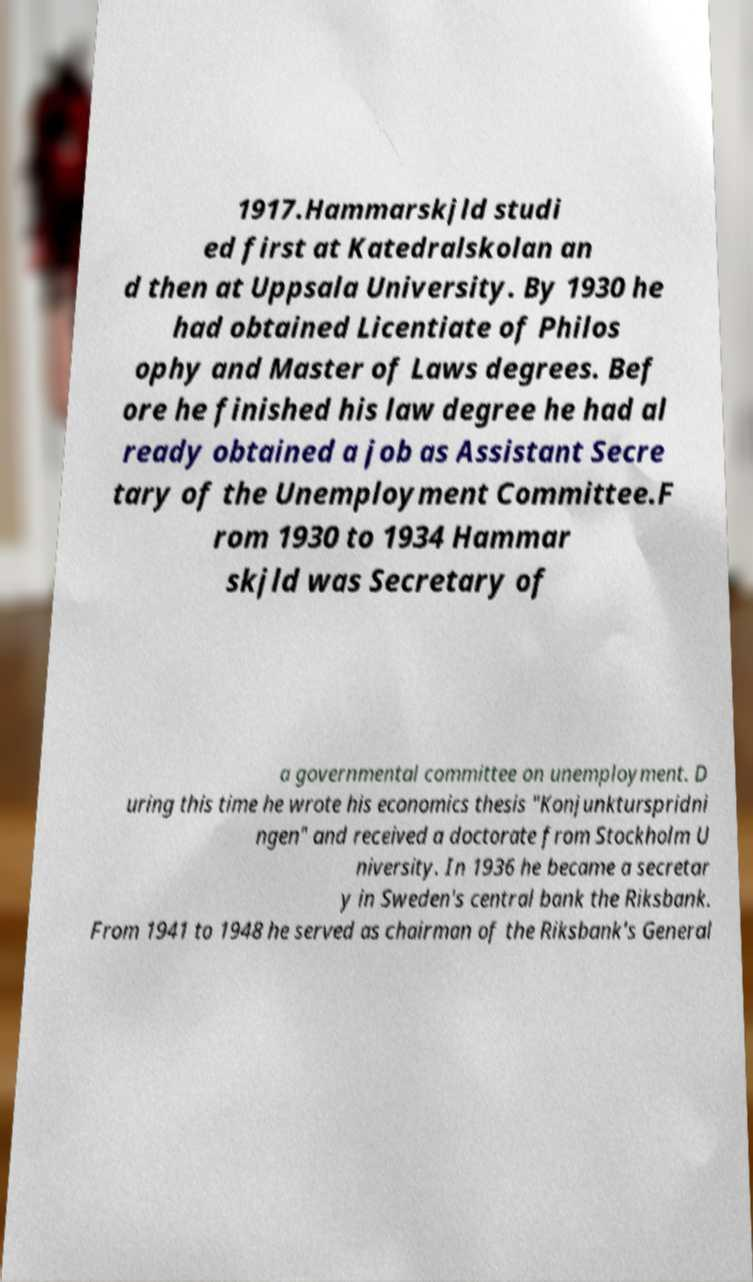Please read and relay the text visible in this image. What does it say? 1917.Hammarskjld studi ed first at Katedralskolan an d then at Uppsala University. By 1930 he had obtained Licentiate of Philos ophy and Master of Laws degrees. Bef ore he finished his law degree he had al ready obtained a job as Assistant Secre tary of the Unemployment Committee.F rom 1930 to 1934 Hammar skjld was Secretary of a governmental committee on unemployment. D uring this time he wrote his economics thesis "Konjunkturspridni ngen" and received a doctorate from Stockholm U niversity. In 1936 he became a secretar y in Sweden's central bank the Riksbank. From 1941 to 1948 he served as chairman of the Riksbank's General 